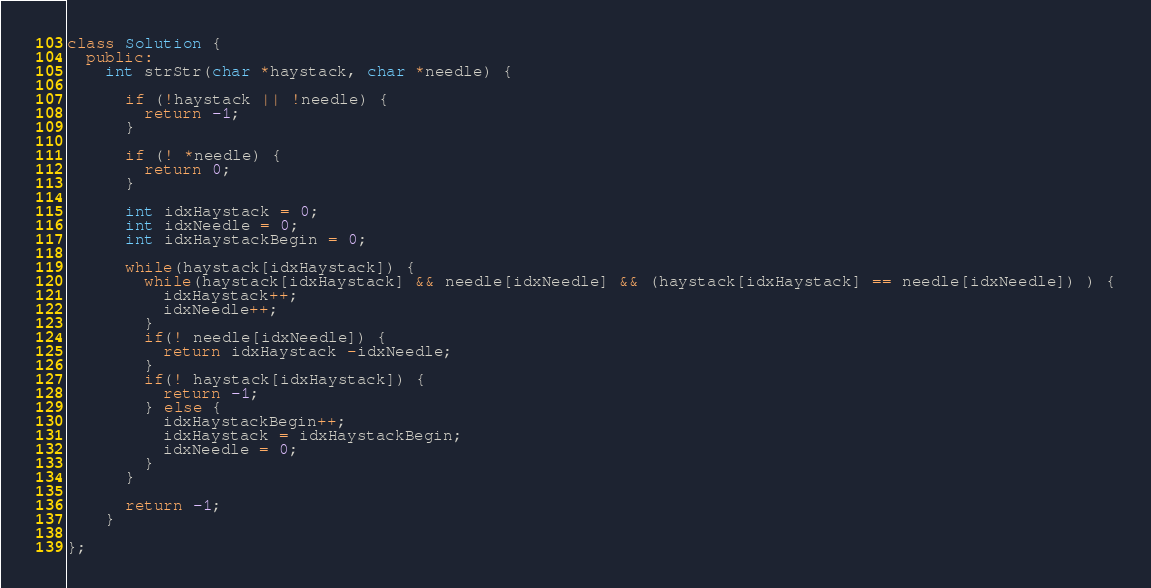Convert code to text. <code><loc_0><loc_0><loc_500><loc_500><_C++_>class Solution {
  public:
    int strStr(char *haystack, char *needle) {

      if (!haystack || !needle) {
        return -1;
      }

      if (! *needle) {
        return 0;
      }

      int idxHaystack = 0;
      int idxNeedle = 0;
      int idxHaystackBegin = 0;

      while(haystack[idxHaystack]) {
        while(haystack[idxHaystack] && needle[idxNeedle] && (haystack[idxHaystack] == needle[idxNeedle]) ) {
          idxHaystack++;
          idxNeedle++;
        }
        if(! needle[idxNeedle]) {
          return idxHaystack -idxNeedle;
        }
        if(! haystack[idxHaystack]) {
          return -1;
        } else {
          idxHaystackBegin++;
          idxHaystack = idxHaystackBegin;
          idxNeedle = 0;
        }
      }

      return -1;
    }

};
</code> 